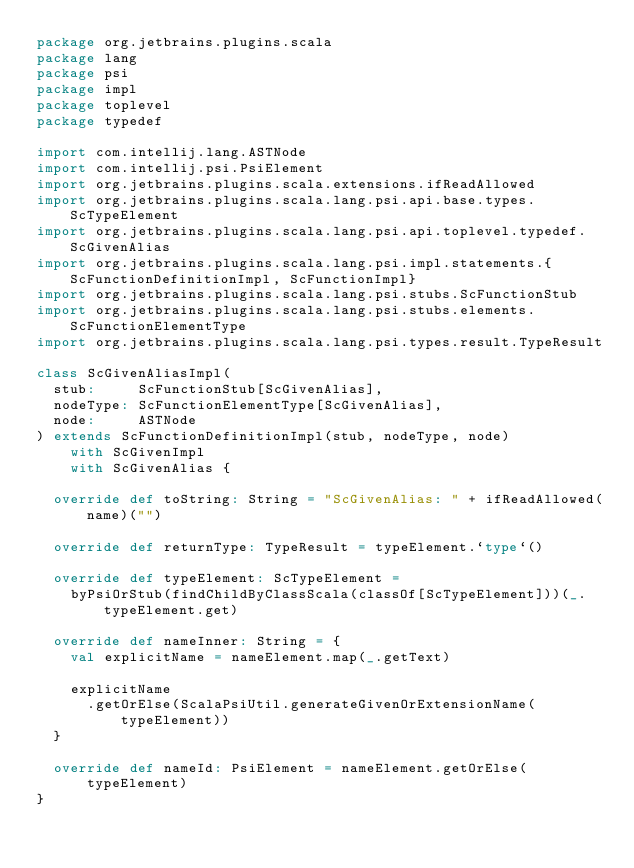Convert code to text. <code><loc_0><loc_0><loc_500><loc_500><_Scala_>package org.jetbrains.plugins.scala
package lang
package psi
package impl
package toplevel
package typedef

import com.intellij.lang.ASTNode
import com.intellij.psi.PsiElement
import org.jetbrains.plugins.scala.extensions.ifReadAllowed
import org.jetbrains.plugins.scala.lang.psi.api.base.types.ScTypeElement
import org.jetbrains.plugins.scala.lang.psi.api.toplevel.typedef.ScGivenAlias
import org.jetbrains.plugins.scala.lang.psi.impl.statements.{ScFunctionDefinitionImpl, ScFunctionImpl}
import org.jetbrains.plugins.scala.lang.psi.stubs.ScFunctionStub
import org.jetbrains.plugins.scala.lang.psi.stubs.elements.ScFunctionElementType
import org.jetbrains.plugins.scala.lang.psi.types.result.TypeResult

class ScGivenAliasImpl(
  stub:     ScFunctionStub[ScGivenAlias],
  nodeType: ScFunctionElementType[ScGivenAlias],
  node:     ASTNode
) extends ScFunctionDefinitionImpl(stub, nodeType, node)
    with ScGivenImpl
    with ScGivenAlias {

  override def toString: String = "ScGivenAlias: " + ifReadAllowed(name)("")

  override def returnType: TypeResult = typeElement.`type`()

  override def typeElement: ScTypeElement =
    byPsiOrStub(findChildByClassScala(classOf[ScTypeElement]))(_.typeElement.get)

  override def nameInner: String = {
    val explicitName = nameElement.map(_.getText)

    explicitName
      .getOrElse(ScalaPsiUtil.generateGivenOrExtensionName(typeElement))
  }

  override def nameId: PsiElement = nameElement.getOrElse(typeElement)
}
</code> 